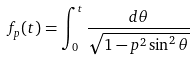Convert formula to latex. <formula><loc_0><loc_0><loc_500><loc_500>f _ { p } ( t ) = \int _ { 0 } ^ { t } \frac { d \theta } { \sqrt { 1 - p ^ { 2 } \sin ^ { 2 } \theta } }</formula> 